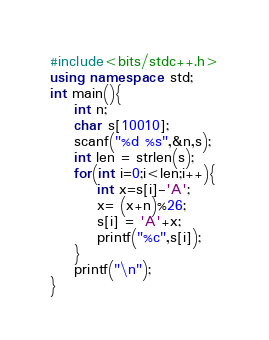<code> <loc_0><loc_0><loc_500><loc_500><_C++_>#include<bits/stdc++.h>
using namespace std;
int main(){
    int n;
    char s[10010];
    scanf("%d %s",&n,s);
    int len = strlen(s);
    for(int i=0;i<len;i++){
        int x=s[i]-'A';
        x= (x+n)%26;
        s[i] = 'A'+x;
        printf("%c",s[i]);
    }
    printf("\n");
}</code> 